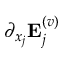<formula> <loc_0><loc_0><loc_500><loc_500>\partial _ { x _ { j } } { E } _ { j } ^ { ( v ) }</formula> 